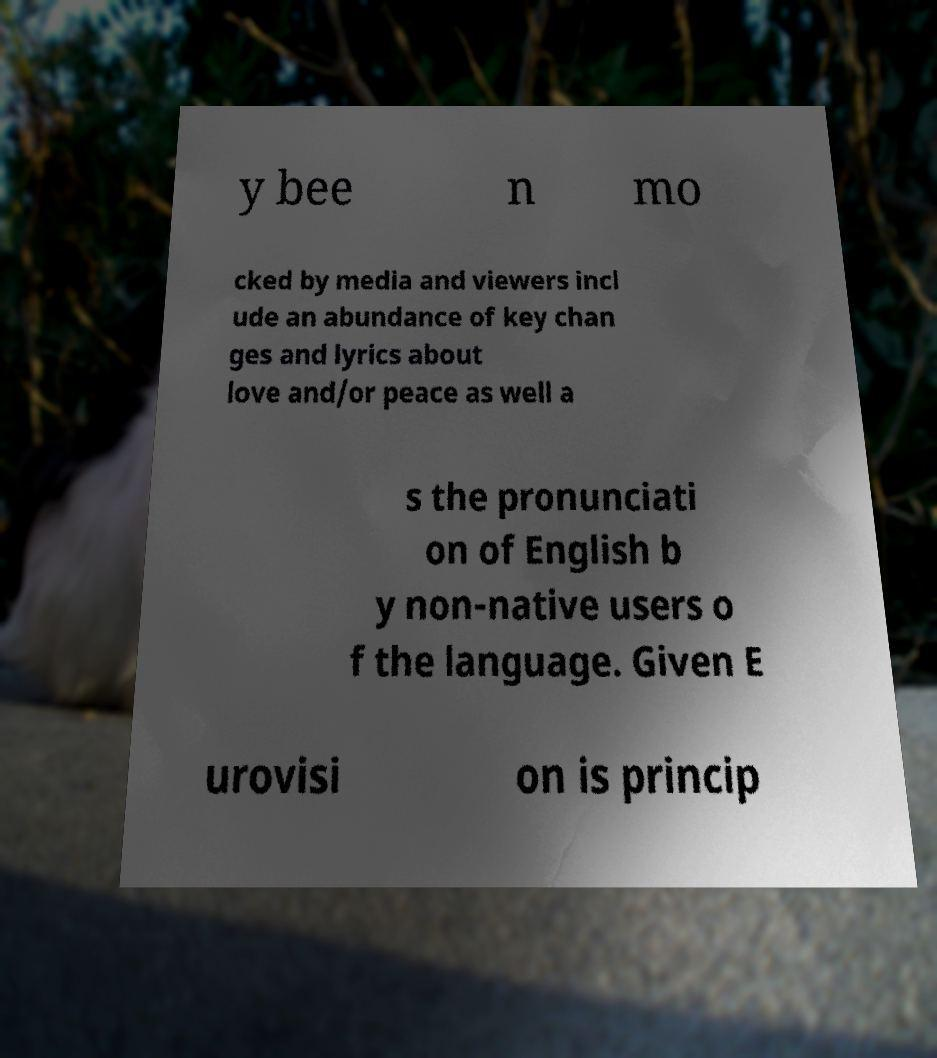Could you extract and type out the text from this image? y bee n mo cked by media and viewers incl ude an abundance of key chan ges and lyrics about love and/or peace as well a s the pronunciati on of English b y non-native users o f the language. Given E urovisi on is princip 